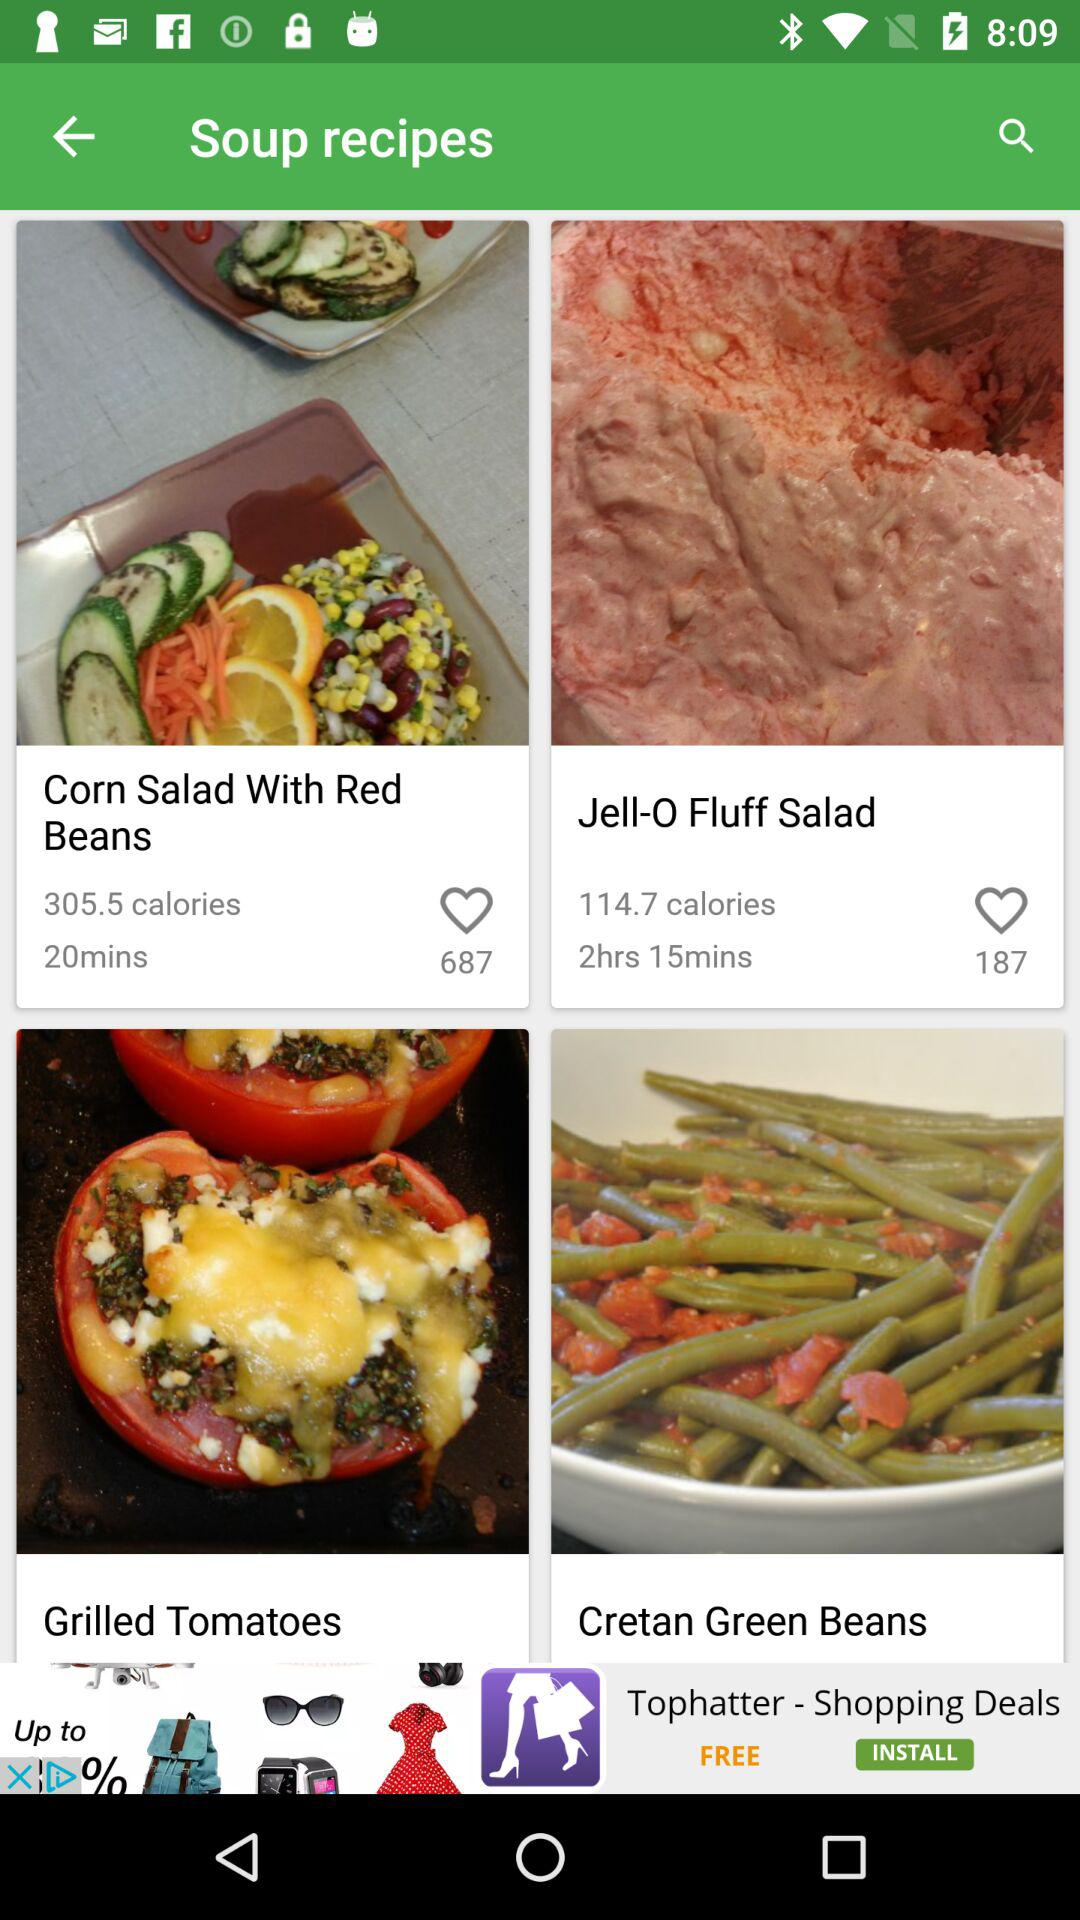How many calories are in "Corn Salad With Red"? There are 305.5 calories. 